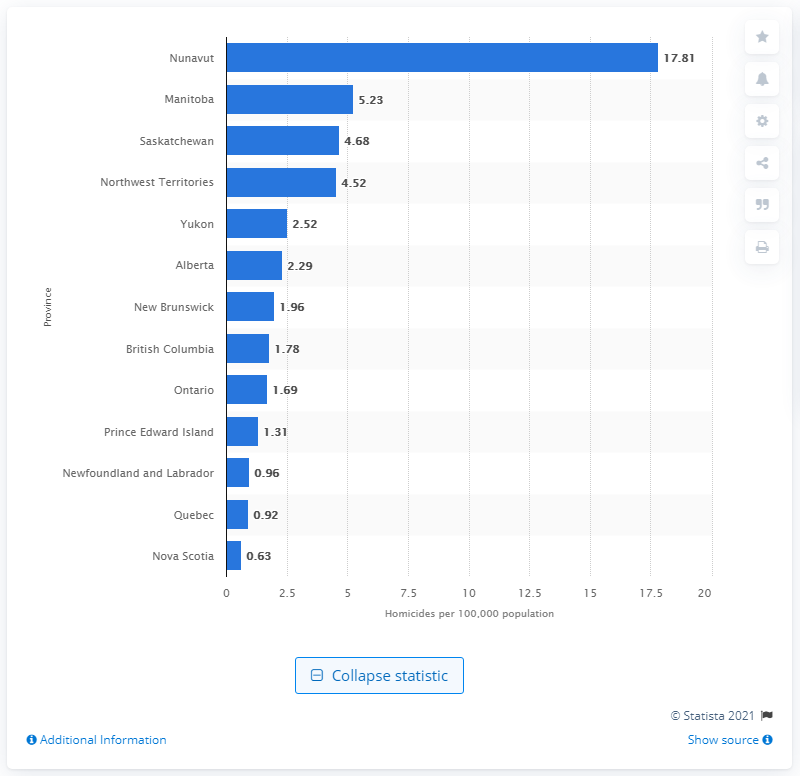Identify some key points in this picture. In 2019, the murder rate in Nunavut was 17.81 per 100,000 residents. 